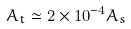<formula> <loc_0><loc_0><loc_500><loc_500>A _ { t } \simeq 2 \times 1 0 ^ { - 4 } A _ { s }</formula> 